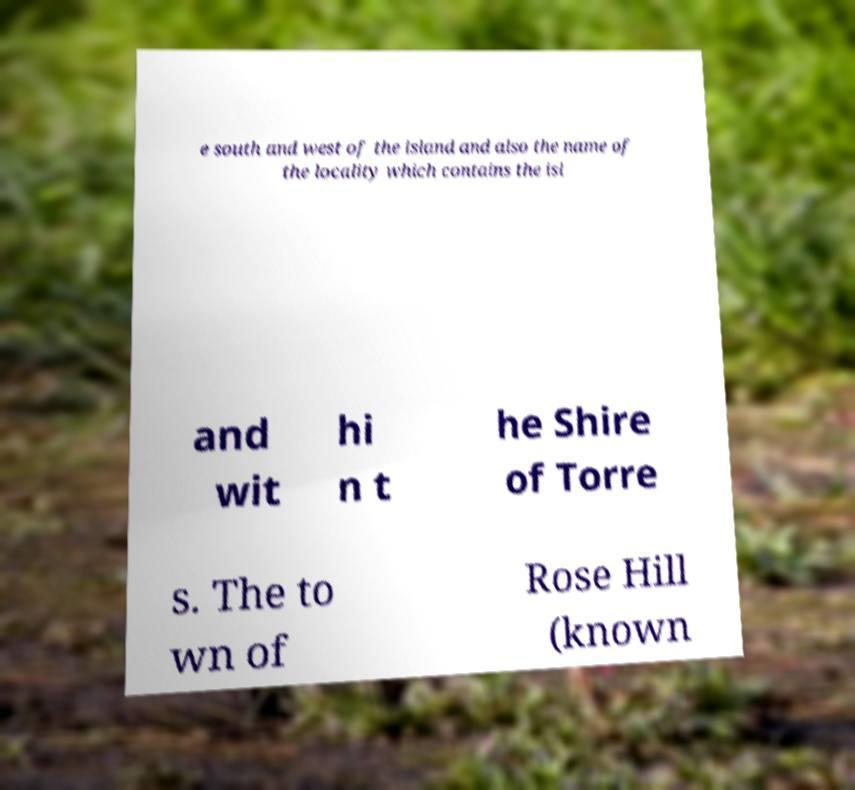Can you read and provide the text displayed in the image?This photo seems to have some interesting text. Can you extract and type it out for me? e south and west of the island and also the name of the locality which contains the isl and wit hi n t he Shire of Torre s. The to wn of Rose Hill (known 